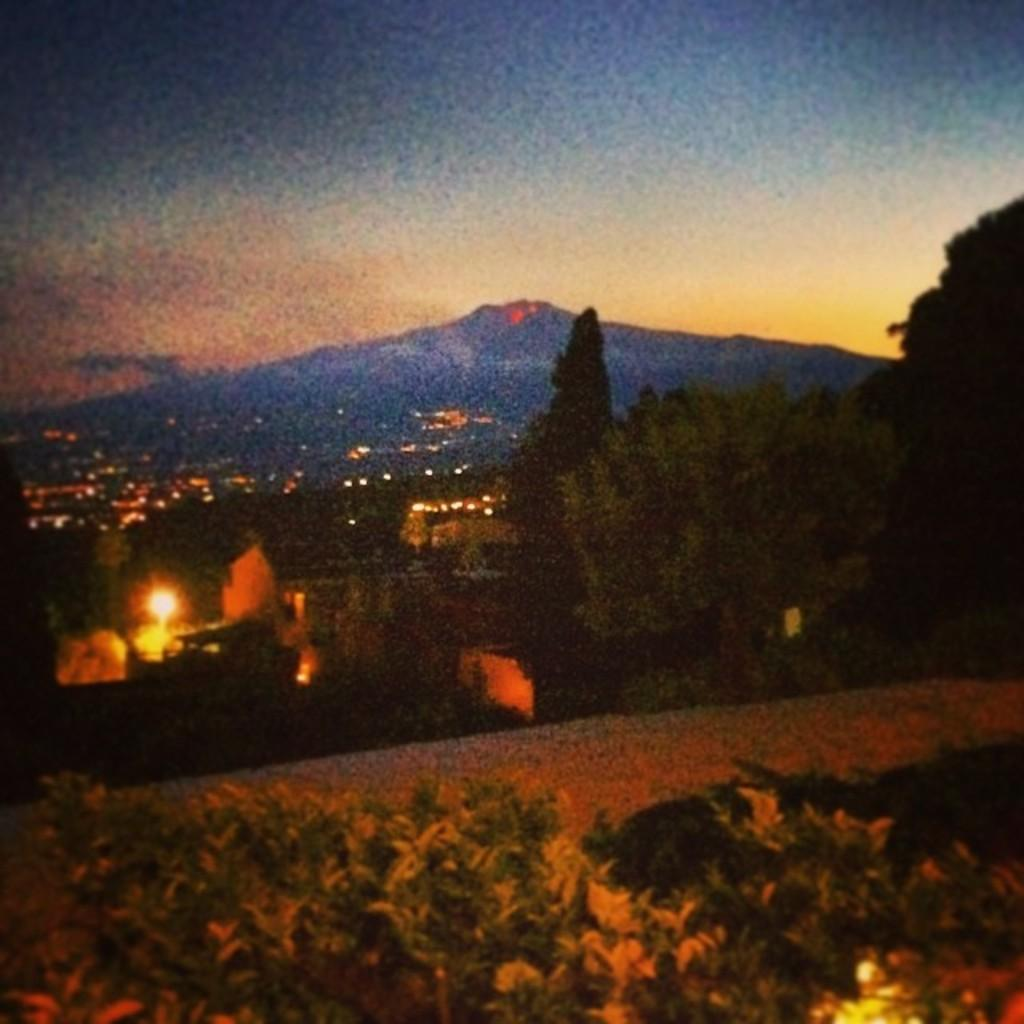What is located in the center of the image? There are trees and buildings in the center of the image. What can be seen illuminated in the image? Lights are visible in the image. What type of vegetation is at the bottom of the image? There are plants at the bottom of the image. What is visible in the background of the image? There is a hill and the sky visible in the background of the image. What type of toy is being controlled by the hill in the image? There is no toy present in the image, and the hill is not controlling anything. 